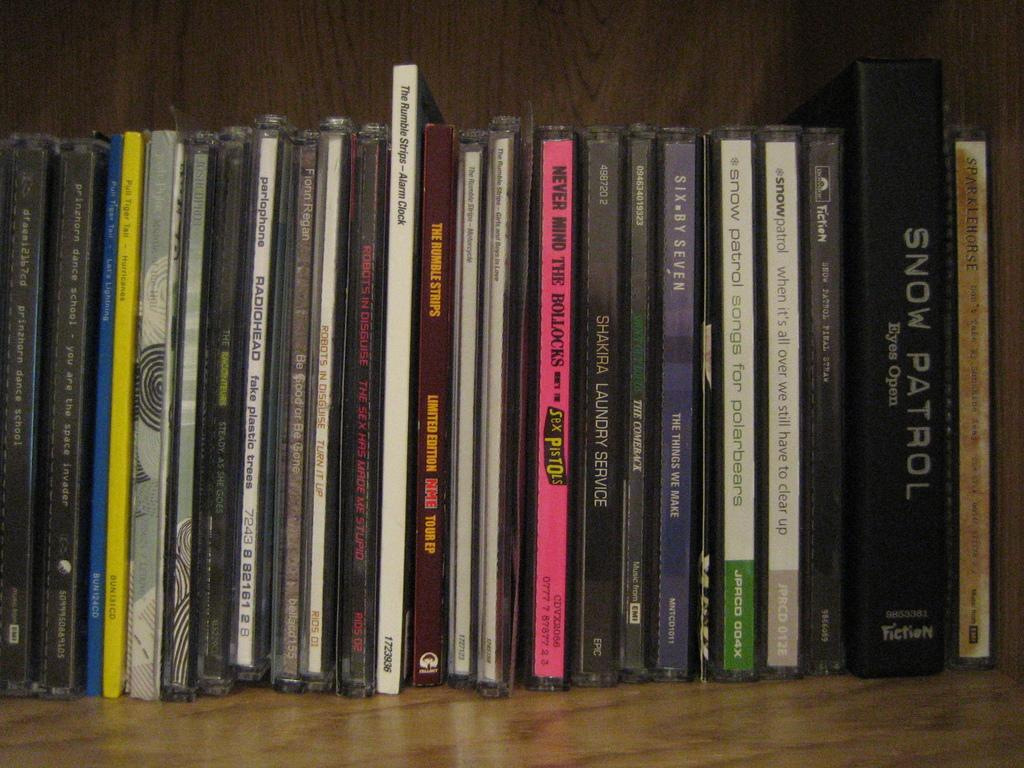<image>
Provide a brief description of the given image. Snow Patron Eyes Open sits on a shelf next too other Snow Patrol movies 